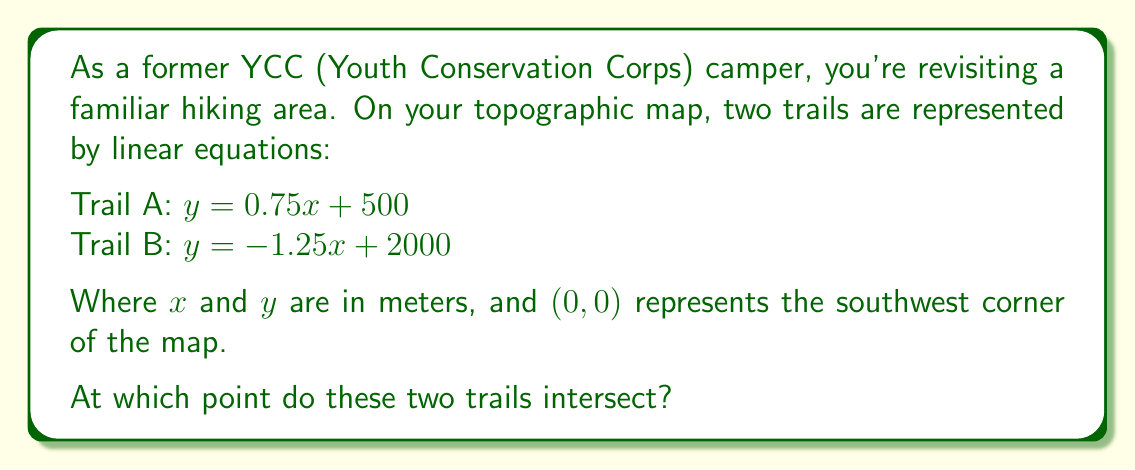Show me your answer to this math problem. To find the intersection point of the two trails, we need to solve the system of linear equations:

$$\begin{cases}
y = 0.75x + 500 \\
y = -1.25x + 2000
\end{cases}$$

1) Since both equations are equal to $y$, we can set them equal to each other:

   $0.75x + 500 = -1.25x + 2000$

2) Subtract $0.75x$ from both sides:

   $500 = -2x + 2000$

3) Subtract 2000 from both sides:

   $-1500 = -2x$

4) Divide both sides by -2:

   $750 = x$

5) Now that we know $x$, we can substitute it into either of the original equations. Let's use Trail A:

   $y = 0.75(750) + 500$
   $y = 562.5 + 500 = 1062.5$

Therefore, the intersection point is $(750, 1062.5)$.
Answer: The trails intersect at the point $(750, 1062.5)$ meters from the southwest corner of the map. 